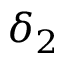Convert formula to latex. <formula><loc_0><loc_0><loc_500><loc_500>\delta _ { 2 }</formula> 